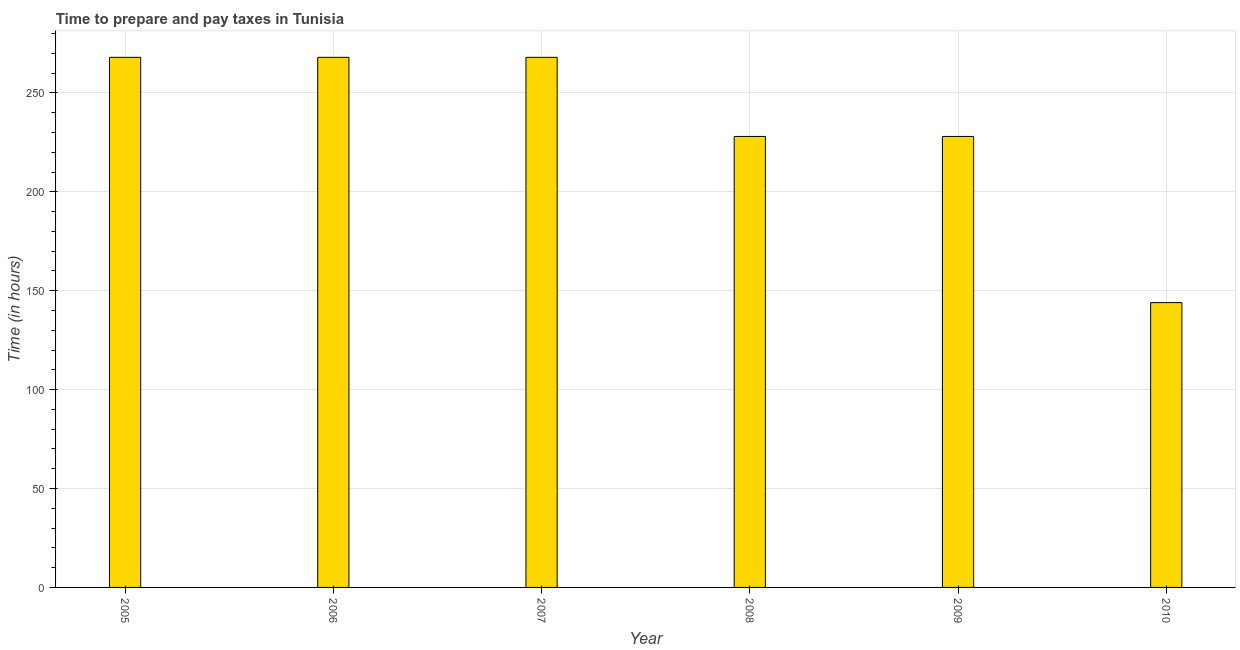Does the graph contain any zero values?
Provide a short and direct response. No. What is the title of the graph?
Your response must be concise. Time to prepare and pay taxes in Tunisia. What is the label or title of the X-axis?
Your answer should be compact. Year. What is the label or title of the Y-axis?
Your answer should be very brief. Time (in hours). What is the time to prepare and pay taxes in 2010?
Offer a terse response. 144. Across all years, what is the maximum time to prepare and pay taxes?
Provide a succinct answer. 268. Across all years, what is the minimum time to prepare and pay taxes?
Ensure brevity in your answer.  144. In which year was the time to prepare and pay taxes maximum?
Keep it short and to the point. 2005. In which year was the time to prepare and pay taxes minimum?
Offer a terse response. 2010. What is the sum of the time to prepare and pay taxes?
Make the answer very short. 1404. What is the difference between the time to prepare and pay taxes in 2006 and 2007?
Provide a succinct answer. 0. What is the average time to prepare and pay taxes per year?
Offer a terse response. 234. What is the median time to prepare and pay taxes?
Keep it short and to the point. 248. In how many years, is the time to prepare and pay taxes greater than 230 hours?
Provide a succinct answer. 3. Do a majority of the years between 2010 and 2005 (inclusive) have time to prepare and pay taxes greater than 250 hours?
Your response must be concise. Yes. What is the ratio of the time to prepare and pay taxes in 2007 to that in 2008?
Your answer should be compact. 1.18. Is the time to prepare and pay taxes in 2007 less than that in 2010?
Provide a short and direct response. No. What is the difference between the highest and the lowest time to prepare and pay taxes?
Give a very brief answer. 124. In how many years, is the time to prepare and pay taxes greater than the average time to prepare and pay taxes taken over all years?
Ensure brevity in your answer.  3. What is the difference between two consecutive major ticks on the Y-axis?
Give a very brief answer. 50. What is the Time (in hours) of 2005?
Your answer should be compact. 268. What is the Time (in hours) in 2006?
Offer a very short reply. 268. What is the Time (in hours) in 2007?
Offer a terse response. 268. What is the Time (in hours) in 2008?
Your answer should be compact. 228. What is the Time (in hours) of 2009?
Provide a succinct answer. 228. What is the Time (in hours) of 2010?
Your answer should be very brief. 144. What is the difference between the Time (in hours) in 2005 and 2010?
Provide a short and direct response. 124. What is the difference between the Time (in hours) in 2006 and 2008?
Your response must be concise. 40. What is the difference between the Time (in hours) in 2006 and 2010?
Keep it short and to the point. 124. What is the difference between the Time (in hours) in 2007 and 2010?
Give a very brief answer. 124. What is the difference between the Time (in hours) in 2008 and 2010?
Your response must be concise. 84. What is the ratio of the Time (in hours) in 2005 to that in 2007?
Offer a terse response. 1. What is the ratio of the Time (in hours) in 2005 to that in 2008?
Your answer should be very brief. 1.18. What is the ratio of the Time (in hours) in 2005 to that in 2009?
Ensure brevity in your answer.  1.18. What is the ratio of the Time (in hours) in 2005 to that in 2010?
Make the answer very short. 1.86. What is the ratio of the Time (in hours) in 2006 to that in 2007?
Your answer should be very brief. 1. What is the ratio of the Time (in hours) in 2006 to that in 2008?
Provide a short and direct response. 1.18. What is the ratio of the Time (in hours) in 2006 to that in 2009?
Provide a succinct answer. 1.18. What is the ratio of the Time (in hours) in 2006 to that in 2010?
Offer a terse response. 1.86. What is the ratio of the Time (in hours) in 2007 to that in 2008?
Ensure brevity in your answer.  1.18. What is the ratio of the Time (in hours) in 2007 to that in 2009?
Your answer should be compact. 1.18. What is the ratio of the Time (in hours) in 2007 to that in 2010?
Provide a succinct answer. 1.86. What is the ratio of the Time (in hours) in 2008 to that in 2009?
Offer a terse response. 1. What is the ratio of the Time (in hours) in 2008 to that in 2010?
Ensure brevity in your answer.  1.58. What is the ratio of the Time (in hours) in 2009 to that in 2010?
Provide a succinct answer. 1.58. 